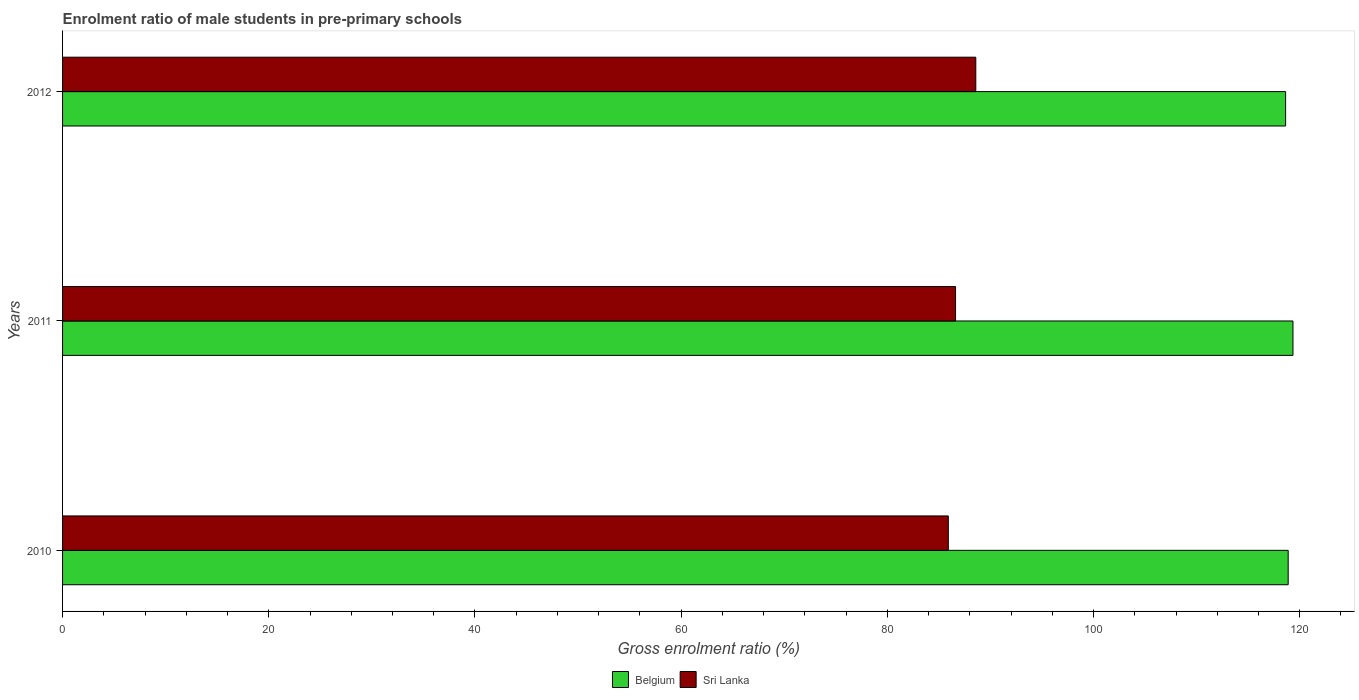How many different coloured bars are there?
Provide a succinct answer. 2. Are the number of bars per tick equal to the number of legend labels?
Keep it short and to the point. Yes. Are the number of bars on each tick of the Y-axis equal?
Offer a terse response. Yes. How many bars are there on the 3rd tick from the top?
Your answer should be compact. 2. How many bars are there on the 3rd tick from the bottom?
Provide a short and direct response. 2. What is the enrolment ratio of male students in pre-primary schools in Belgium in 2011?
Provide a succinct answer. 119.34. Across all years, what is the maximum enrolment ratio of male students in pre-primary schools in Sri Lanka?
Offer a very short reply. 88.58. Across all years, what is the minimum enrolment ratio of male students in pre-primary schools in Sri Lanka?
Offer a very short reply. 85.91. In which year was the enrolment ratio of male students in pre-primary schools in Sri Lanka maximum?
Your answer should be compact. 2012. In which year was the enrolment ratio of male students in pre-primary schools in Belgium minimum?
Offer a very short reply. 2012. What is the total enrolment ratio of male students in pre-primary schools in Sri Lanka in the graph?
Provide a succinct answer. 261.11. What is the difference between the enrolment ratio of male students in pre-primary schools in Sri Lanka in 2010 and that in 2012?
Make the answer very short. -2.67. What is the difference between the enrolment ratio of male students in pre-primary schools in Sri Lanka in 2010 and the enrolment ratio of male students in pre-primary schools in Belgium in 2012?
Keep it short and to the point. -32.72. What is the average enrolment ratio of male students in pre-primary schools in Belgium per year?
Your answer should be very brief. 118.95. In the year 2012, what is the difference between the enrolment ratio of male students in pre-primary schools in Belgium and enrolment ratio of male students in pre-primary schools in Sri Lanka?
Ensure brevity in your answer.  30.05. What is the ratio of the enrolment ratio of male students in pre-primary schools in Belgium in 2010 to that in 2012?
Make the answer very short. 1. Is the enrolment ratio of male students in pre-primary schools in Belgium in 2010 less than that in 2011?
Your answer should be very brief. Yes. Is the difference between the enrolment ratio of male students in pre-primary schools in Belgium in 2011 and 2012 greater than the difference between the enrolment ratio of male students in pre-primary schools in Sri Lanka in 2011 and 2012?
Provide a succinct answer. Yes. What is the difference between the highest and the second highest enrolment ratio of male students in pre-primary schools in Sri Lanka?
Your response must be concise. 1.96. What is the difference between the highest and the lowest enrolment ratio of male students in pre-primary schools in Sri Lanka?
Provide a succinct answer. 2.67. What does the 1st bar from the top in 2010 represents?
Ensure brevity in your answer.  Sri Lanka. What does the 2nd bar from the bottom in 2012 represents?
Your response must be concise. Sri Lanka. Are all the bars in the graph horizontal?
Keep it short and to the point. Yes. Does the graph contain any zero values?
Make the answer very short. No. Does the graph contain grids?
Provide a short and direct response. No. Where does the legend appear in the graph?
Provide a short and direct response. Bottom center. How many legend labels are there?
Your response must be concise. 2. What is the title of the graph?
Provide a short and direct response. Enrolment ratio of male students in pre-primary schools. What is the label or title of the X-axis?
Make the answer very short. Gross enrolment ratio (%). What is the Gross enrolment ratio (%) of Belgium in 2010?
Your answer should be compact. 118.88. What is the Gross enrolment ratio (%) of Sri Lanka in 2010?
Keep it short and to the point. 85.91. What is the Gross enrolment ratio (%) in Belgium in 2011?
Your answer should be compact. 119.34. What is the Gross enrolment ratio (%) in Sri Lanka in 2011?
Offer a terse response. 86.62. What is the Gross enrolment ratio (%) of Belgium in 2012?
Your answer should be very brief. 118.63. What is the Gross enrolment ratio (%) of Sri Lanka in 2012?
Provide a succinct answer. 88.58. Across all years, what is the maximum Gross enrolment ratio (%) of Belgium?
Make the answer very short. 119.34. Across all years, what is the maximum Gross enrolment ratio (%) of Sri Lanka?
Your answer should be very brief. 88.58. Across all years, what is the minimum Gross enrolment ratio (%) of Belgium?
Your response must be concise. 118.63. Across all years, what is the minimum Gross enrolment ratio (%) of Sri Lanka?
Ensure brevity in your answer.  85.91. What is the total Gross enrolment ratio (%) in Belgium in the graph?
Offer a very short reply. 356.86. What is the total Gross enrolment ratio (%) in Sri Lanka in the graph?
Offer a terse response. 261.11. What is the difference between the Gross enrolment ratio (%) of Belgium in 2010 and that in 2011?
Offer a very short reply. -0.46. What is the difference between the Gross enrolment ratio (%) of Sri Lanka in 2010 and that in 2011?
Ensure brevity in your answer.  -0.7. What is the difference between the Gross enrolment ratio (%) of Belgium in 2010 and that in 2012?
Your response must be concise. 0.25. What is the difference between the Gross enrolment ratio (%) of Sri Lanka in 2010 and that in 2012?
Provide a short and direct response. -2.67. What is the difference between the Gross enrolment ratio (%) of Belgium in 2011 and that in 2012?
Offer a very short reply. 0.71. What is the difference between the Gross enrolment ratio (%) of Sri Lanka in 2011 and that in 2012?
Provide a succinct answer. -1.96. What is the difference between the Gross enrolment ratio (%) in Belgium in 2010 and the Gross enrolment ratio (%) in Sri Lanka in 2011?
Give a very brief answer. 32.26. What is the difference between the Gross enrolment ratio (%) of Belgium in 2010 and the Gross enrolment ratio (%) of Sri Lanka in 2012?
Give a very brief answer. 30.3. What is the difference between the Gross enrolment ratio (%) of Belgium in 2011 and the Gross enrolment ratio (%) of Sri Lanka in 2012?
Provide a short and direct response. 30.77. What is the average Gross enrolment ratio (%) in Belgium per year?
Offer a terse response. 118.95. What is the average Gross enrolment ratio (%) in Sri Lanka per year?
Offer a terse response. 87.04. In the year 2010, what is the difference between the Gross enrolment ratio (%) of Belgium and Gross enrolment ratio (%) of Sri Lanka?
Your answer should be compact. 32.97. In the year 2011, what is the difference between the Gross enrolment ratio (%) of Belgium and Gross enrolment ratio (%) of Sri Lanka?
Provide a succinct answer. 32.73. In the year 2012, what is the difference between the Gross enrolment ratio (%) in Belgium and Gross enrolment ratio (%) in Sri Lanka?
Make the answer very short. 30.05. What is the ratio of the Gross enrolment ratio (%) of Sri Lanka in 2010 to that in 2011?
Offer a terse response. 0.99. What is the ratio of the Gross enrolment ratio (%) in Sri Lanka in 2010 to that in 2012?
Your answer should be compact. 0.97. What is the ratio of the Gross enrolment ratio (%) of Sri Lanka in 2011 to that in 2012?
Your response must be concise. 0.98. What is the difference between the highest and the second highest Gross enrolment ratio (%) of Belgium?
Your answer should be very brief. 0.46. What is the difference between the highest and the second highest Gross enrolment ratio (%) in Sri Lanka?
Your answer should be very brief. 1.96. What is the difference between the highest and the lowest Gross enrolment ratio (%) in Belgium?
Offer a terse response. 0.71. What is the difference between the highest and the lowest Gross enrolment ratio (%) in Sri Lanka?
Provide a succinct answer. 2.67. 